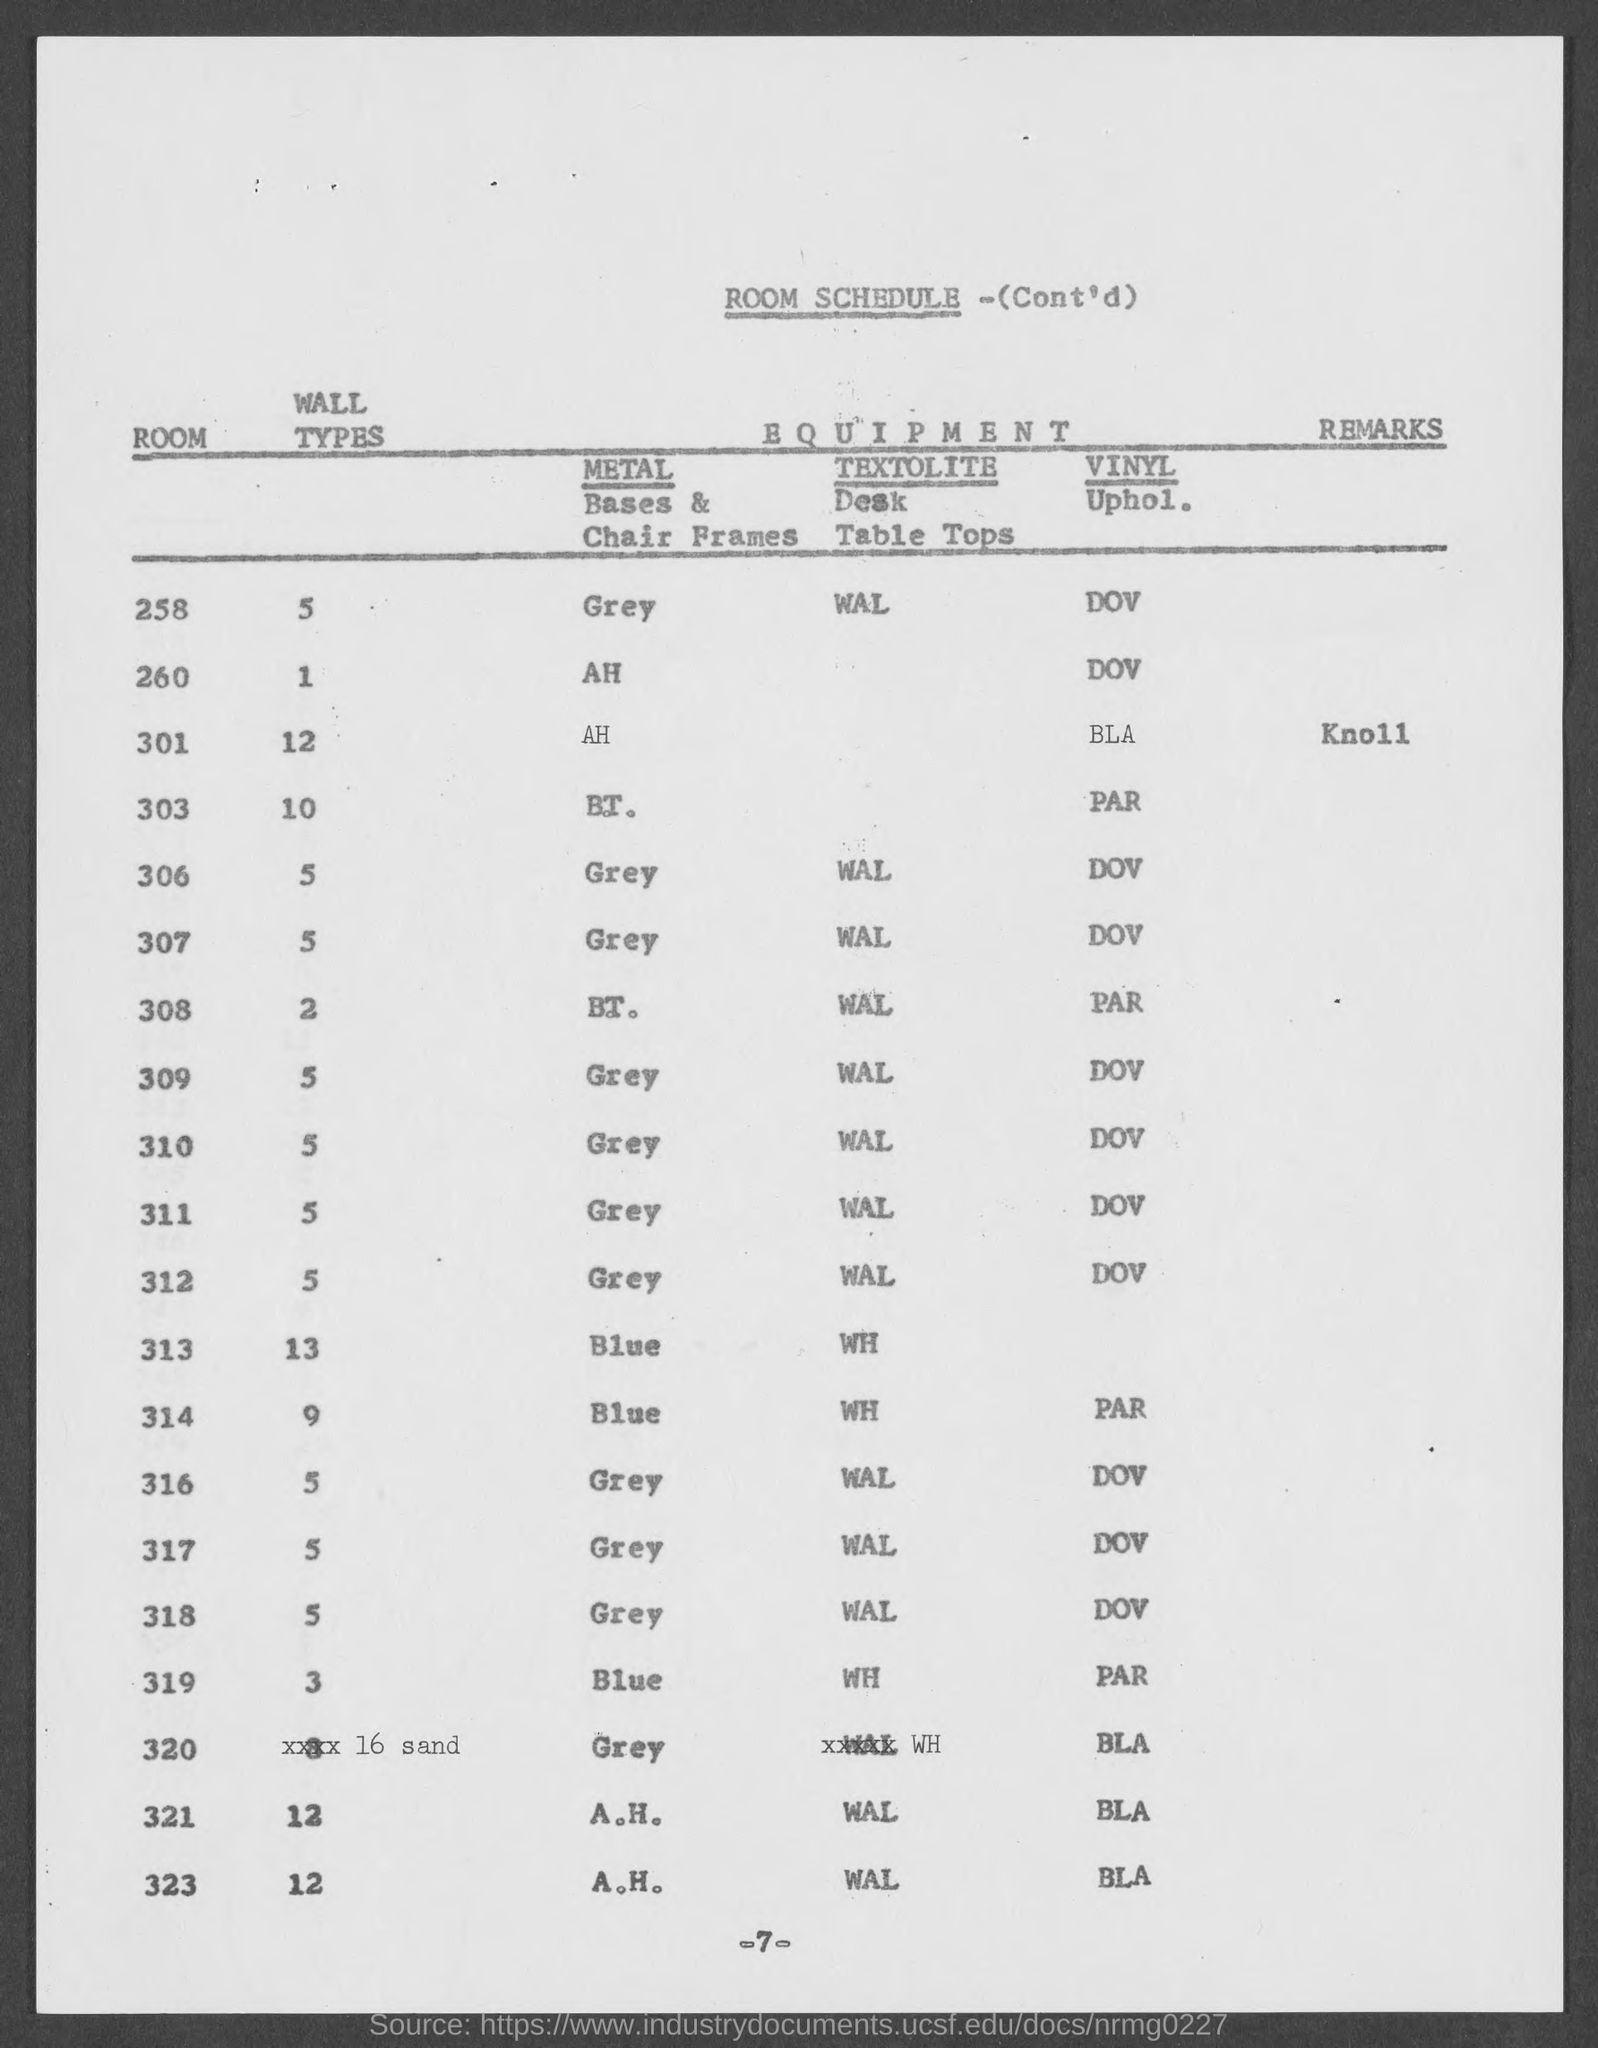Draw attention to some important aspects in this diagram. What is the page number? The page number is -7-. In Room 308, the wall types are two. 